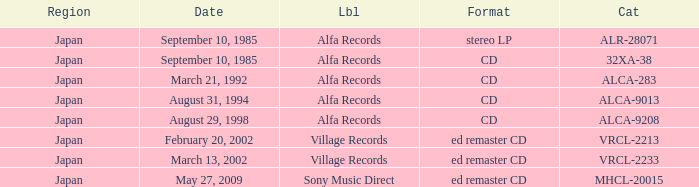Which Catalog was formated as a CD under the label Alfa Records? 32XA-38, ALCA-283, ALCA-9013, ALCA-9208. 